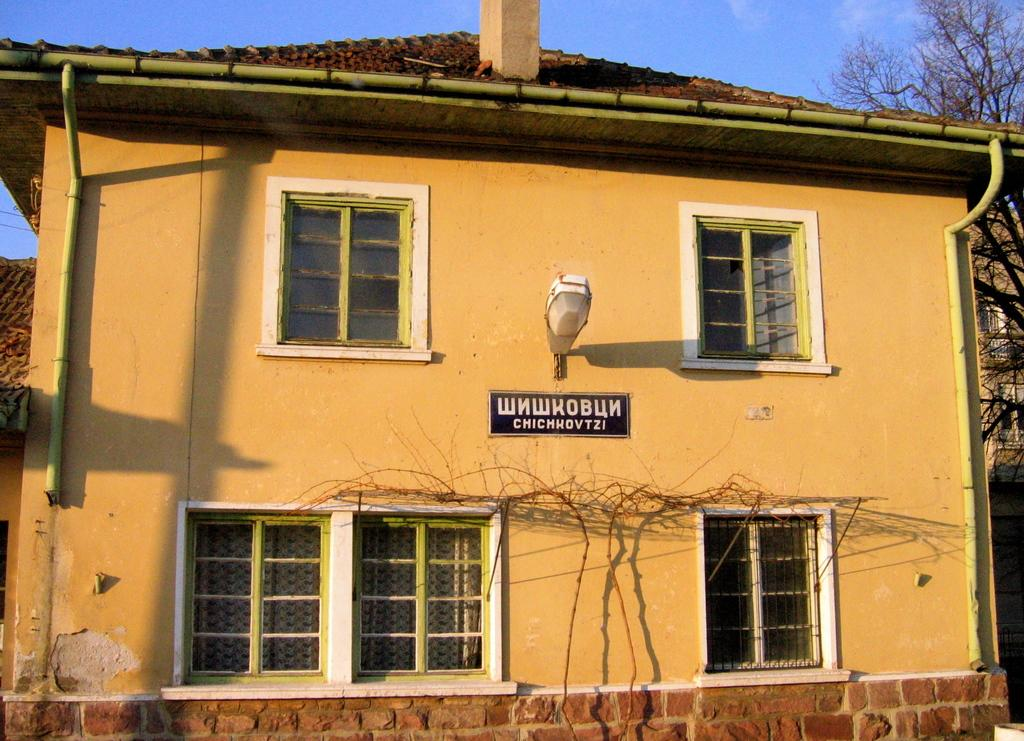<image>
Describe the image concisely. a building that has the Russian language on it 